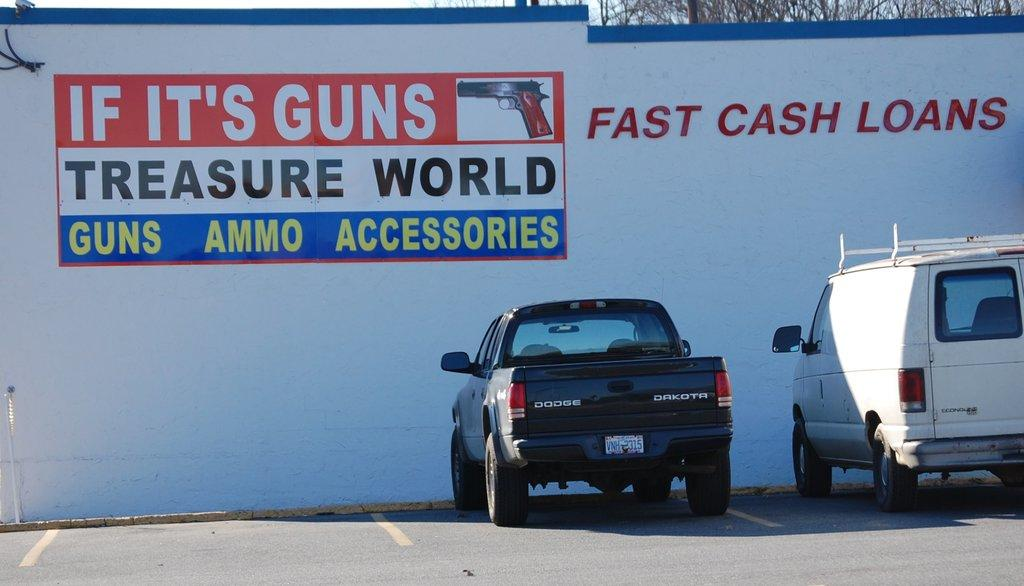<image>
Summarize the visual content of the image. Two vehicles are parked next to a building with a sign for Treasure World. 